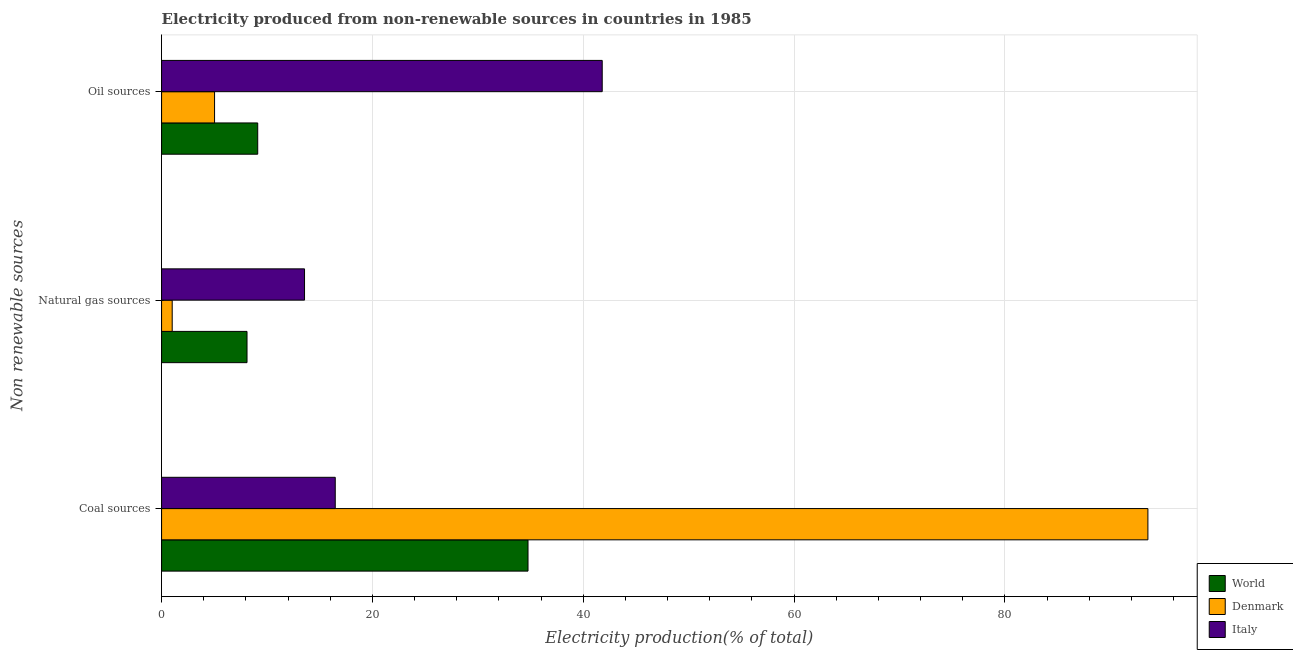How many different coloured bars are there?
Keep it short and to the point. 3. How many groups of bars are there?
Provide a succinct answer. 3. Are the number of bars per tick equal to the number of legend labels?
Keep it short and to the point. Yes. Are the number of bars on each tick of the Y-axis equal?
Provide a succinct answer. Yes. How many bars are there on the 2nd tick from the top?
Keep it short and to the point. 3. What is the label of the 2nd group of bars from the top?
Your answer should be very brief. Natural gas sources. What is the percentage of electricity produced by oil sources in Denmark?
Provide a succinct answer. 5.03. Across all countries, what is the maximum percentage of electricity produced by natural gas?
Make the answer very short. 13.56. Across all countries, what is the minimum percentage of electricity produced by oil sources?
Your answer should be very brief. 5.03. What is the total percentage of electricity produced by oil sources in the graph?
Make the answer very short. 55.95. What is the difference between the percentage of electricity produced by natural gas in World and that in Denmark?
Make the answer very short. 7.1. What is the difference between the percentage of electricity produced by natural gas in Denmark and the percentage of electricity produced by oil sources in Italy?
Ensure brevity in your answer.  -40.79. What is the average percentage of electricity produced by natural gas per country?
Your answer should be very brief. 7.56. What is the difference between the percentage of electricity produced by oil sources and percentage of electricity produced by natural gas in Denmark?
Ensure brevity in your answer.  4.02. In how many countries, is the percentage of electricity produced by oil sources greater than 80 %?
Ensure brevity in your answer.  0. What is the ratio of the percentage of electricity produced by natural gas in Italy to that in Denmark?
Your answer should be very brief. 13.44. Is the percentage of electricity produced by coal in World less than that in Denmark?
Ensure brevity in your answer.  Yes. Is the difference between the percentage of electricity produced by coal in Denmark and World greater than the difference between the percentage of electricity produced by natural gas in Denmark and World?
Offer a terse response. Yes. What is the difference between the highest and the second highest percentage of electricity produced by oil sources?
Keep it short and to the point. 32.68. What is the difference between the highest and the lowest percentage of electricity produced by oil sources?
Make the answer very short. 36.77. What does the 2nd bar from the bottom in Coal sources represents?
Ensure brevity in your answer.  Denmark. Is it the case that in every country, the sum of the percentage of electricity produced by coal and percentage of electricity produced by natural gas is greater than the percentage of electricity produced by oil sources?
Provide a succinct answer. No. How many bars are there?
Give a very brief answer. 9. What is the difference between two consecutive major ticks on the X-axis?
Provide a short and direct response. 20. Does the graph contain grids?
Make the answer very short. Yes. Where does the legend appear in the graph?
Keep it short and to the point. Bottom right. How many legend labels are there?
Offer a terse response. 3. How are the legend labels stacked?
Your answer should be compact. Vertical. What is the title of the graph?
Your answer should be very brief. Electricity produced from non-renewable sources in countries in 1985. Does "Guinea" appear as one of the legend labels in the graph?
Keep it short and to the point. No. What is the label or title of the X-axis?
Give a very brief answer. Electricity production(% of total). What is the label or title of the Y-axis?
Offer a very short reply. Non renewable sources. What is the Electricity production(% of total) in World in Coal sources?
Your answer should be compact. 34.76. What is the Electricity production(% of total) of Denmark in Coal sources?
Provide a succinct answer. 93.56. What is the Electricity production(% of total) of Italy in Coal sources?
Make the answer very short. 16.47. What is the Electricity production(% of total) of World in Natural gas sources?
Provide a succinct answer. 8.11. What is the Electricity production(% of total) in Denmark in Natural gas sources?
Keep it short and to the point. 1.01. What is the Electricity production(% of total) in Italy in Natural gas sources?
Provide a succinct answer. 13.56. What is the Electricity production(% of total) of World in Oil sources?
Make the answer very short. 9.12. What is the Electricity production(% of total) of Denmark in Oil sources?
Provide a short and direct response. 5.03. What is the Electricity production(% of total) in Italy in Oil sources?
Offer a terse response. 41.8. Across all Non renewable sources, what is the maximum Electricity production(% of total) in World?
Make the answer very short. 34.76. Across all Non renewable sources, what is the maximum Electricity production(% of total) in Denmark?
Provide a short and direct response. 93.56. Across all Non renewable sources, what is the maximum Electricity production(% of total) in Italy?
Provide a succinct answer. 41.8. Across all Non renewable sources, what is the minimum Electricity production(% of total) in World?
Your response must be concise. 8.11. Across all Non renewable sources, what is the minimum Electricity production(% of total) in Denmark?
Provide a short and direct response. 1.01. Across all Non renewable sources, what is the minimum Electricity production(% of total) of Italy?
Your answer should be very brief. 13.56. What is the total Electricity production(% of total) in World in the graph?
Ensure brevity in your answer.  51.99. What is the total Electricity production(% of total) of Denmark in the graph?
Offer a terse response. 99.6. What is the total Electricity production(% of total) of Italy in the graph?
Your response must be concise. 71.83. What is the difference between the Electricity production(% of total) in World in Coal sources and that in Natural gas sources?
Provide a short and direct response. 26.65. What is the difference between the Electricity production(% of total) in Denmark in Coal sources and that in Natural gas sources?
Ensure brevity in your answer.  92.55. What is the difference between the Electricity production(% of total) in Italy in Coal sources and that in Natural gas sources?
Your response must be concise. 2.91. What is the difference between the Electricity production(% of total) of World in Coal sources and that in Oil sources?
Ensure brevity in your answer.  25.64. What is the difference between the Electricity production(% of total) in Denmark in Coal sources and that in Oil sources?
Your answer should be compact. 88.54. What is the difference between the Electricity production(% of total) of Italy in Coal sources and that in Oil sources?
Ensure brevity in your answer.  -25.32. What is the difference between the Electricity production(% of total) in World in Natural gas sources and that in Oil sources?
Provide a succinct answer. -1.02. What is the difference between the Electricity production(% of total) in Denmark in Natural gas sources and that in Oil sources?
Make the answer very short. -4.02. What is the difference between the Electricity production(% of total) of Italy in Natural gas sources and that in Oil sources?
Your response must be concise. -28.24. What is the difference between the Electricity production(% of total) of World in Coal sources and the Electricity production(% of total) of Denmark in Natural gas sources?
Give a very brief answer. 33.75. What is the difference between the Electricity production(% of total) of World in Coal sources and the Electricity production(% of total) of Italy in Natural gas sources?
Make the answer very short. 21.2. What is the difference between the Electricity production(% of total) of Denmark in Coal sources and the Electricity production(% of total) of Italy in Natural gas sources?
Ensure brevity in your answer.  80. What is the difference between the Electricity production(% of total) of World in Coal sources and the Electricity production(% of total) of Denmark in Oil sources?
Your answer should be compact. 29.73. What is the difference between the Electricity production(% of total) in World in Coal sources and the Electricity production(% of total) in Italy in Oil sources?
Provide a short and direct response. -7.04. What is the difference between the Electricity production(% of total) of Denmark in Coal sources and the Electricity production(% of total) of Italy in Oil sources?
Ensure brevity in your answer.  51.76. What is the difference between the Electricity production(% of total) of World in Natural gas sources and the Electricity production(% of total) of Denmark in Oil sources?
Provide a short and direct response. 3.08. What is the difference between the Electricity production(% of total) of World in Natural gas sources and the Electricity production(% of total) of Italy in Oil sources?
Your answer should be compact. -33.69. What is the difference between the Electricity production(% of total) of Denmark in Natural gas sources and the Electricity production(% of total) of Italy in Oil sources?
Make the answer very short. -40.79. What is the average Electricity production(% of total) of World per Non renewable sources?
Make the answer very short. 17.33. What is the average Electricity production(% of total) in Denmark per Non renewable sources?
Offer a terse response. 33.2. What is the average Electricity production(% of total) in Italy per Non renewable sources?
Provide a short and direct response. 23.94. What is the difference between the Electricity production(% of total) of World and Electricity production(% of total) of Denmark in Coal sources?
Provide a succinct answer. -58.8. What is the difference between the Electricity production(% of total) in World and Electricity production(% of total) in Italy in Coal sources?
Offer a terse response. 18.29. What is the difference between the Electricity production(% of total) in Denmark and Electricity production(% of total) in Italy in Coal sources?
Offer a very short reply. 77.09. What is the difference between the Electricity production(% of total) of World and Electricity production(% of total) of Denmark in Natural gas sources?
Offer a very short reply. 7.1. What is the difference between the Electricity production(% of total) in World and Electricity production(% of total) in Italy in Natural gas sources?
Your answer should be very brief. -5.45. What is the difference between the Electricity production(% of total) of Denmark and Electricity production(% of total) of Italy in Natural gas sources?
Give a very brief answer. -12.55. What is the difference between the Electricity production(% of total) in World and Electricity production(% of total) in Denmark in Oil sources?
Your answer should be very brief. 4.09. What is the difference between the Electricity production(% of total) in World and Electricity production(% of total) in Italy in Oil sources?
Offer a terse response. -32.68. What is the difference between the Electricity production(% of total) of Denmark and Electricity production(% of total) of Italy in Oil sources?
Give a very brief answer. -36.77. What is the ratio of the Electricity production(% of total) in World in Coal sources to that in Natural gas sources?
Offer a very short reply. 4.29. What is the ratio of the Electricity production(% of total) in Denmark in Coal sources to that in Natural gas sources?
Provide a succinct answer. 92.75. What is the ratio of the Electricity production(% of total) in Italy in Coal sources to that in Natural gas sources?
Give a very brief answer. 1.21. What is the ratio of the Electricity production(% of total) in World in Coal sources to that in Oil sources?
Keep it short and to the point. 3.81. What is the ratio of the Electricity production(% of total) of Denmark in Coal sources to that in Oil sources?
Provide a short and direct response. 18.61. What is the ratio of the Electricity production(% of total) in Italy in Coal sources to that in Oil sources?
Your answer should be very brief. 0.39. What is the ratio of the Electricity production(% of total) of World in Natural gas sources to that in Oil sources?
Your answer should be compact. 0.89. What is the ratio of the Electricity production(% of total) in Denmark in Natural gas sources to that in Oil sources?
Make the answer very short. 0.2. What is the ratio of the Electricity production(% of total) of Italy in Natural gas sources to that in Oil sources?
Give a very brief answer. 0.32. What is the difference between the highest and the second highest Electricity production(% of total) of World?
Offer a very short reply. 25.64. What is the difference between the highest and the second highest Electricity production(% of total) in Denmark?
Ensure brevity in your answer.  88.54. What is the difference between the highest and the second highest Electricity production(% of total) in Italy?
Your answer should be compact. 25.32. What is the difference between the highest and the lowest Electricity production(% of total) of World?
Offer a terse response. 26.65. What is the difference between the highest and the lowest Electricity production(% of total) in Denmark?
Ensure brevity in your answer.  92.55. What is the difference between the highest and the lowest Electricity production(% of total) of Italy?
Give a very brief answer. 28.24. 